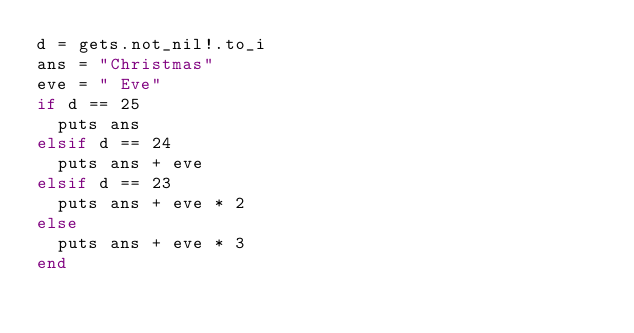<code> <loc_0><loc_0><loc_500><loc_500><_Crystal_>d = gets.not_nil!.to_i
ans = "Christmas"
eve = " Eve"
if d == 25
	puts ans
elsif d == 24
	puts ans + eve
elsif d == 23
	puts ans + eve * 2
else
	puts ans + eve * 3
end</code> 